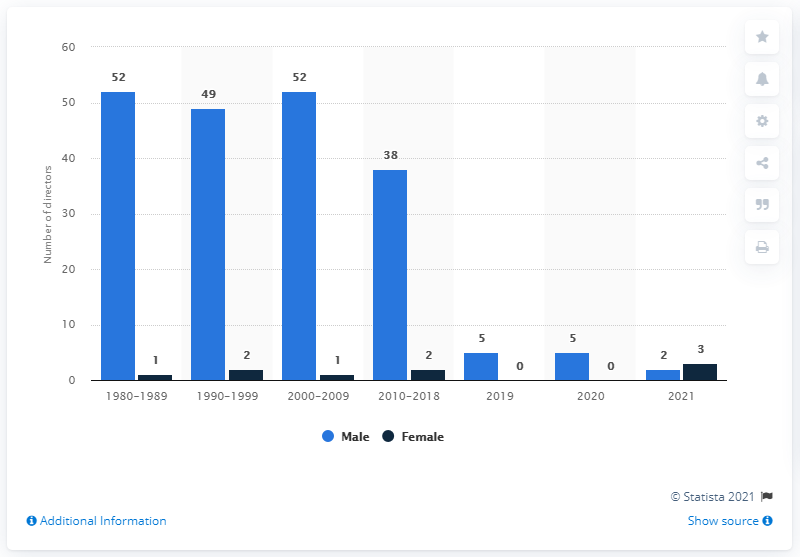Identify some key points in this picture. There were 49 male directors who were nominated for the Golden Globe Best Director Award in the 1990s. In 2021, more women than men were nominated for the Golden Globe Best Director Award. 